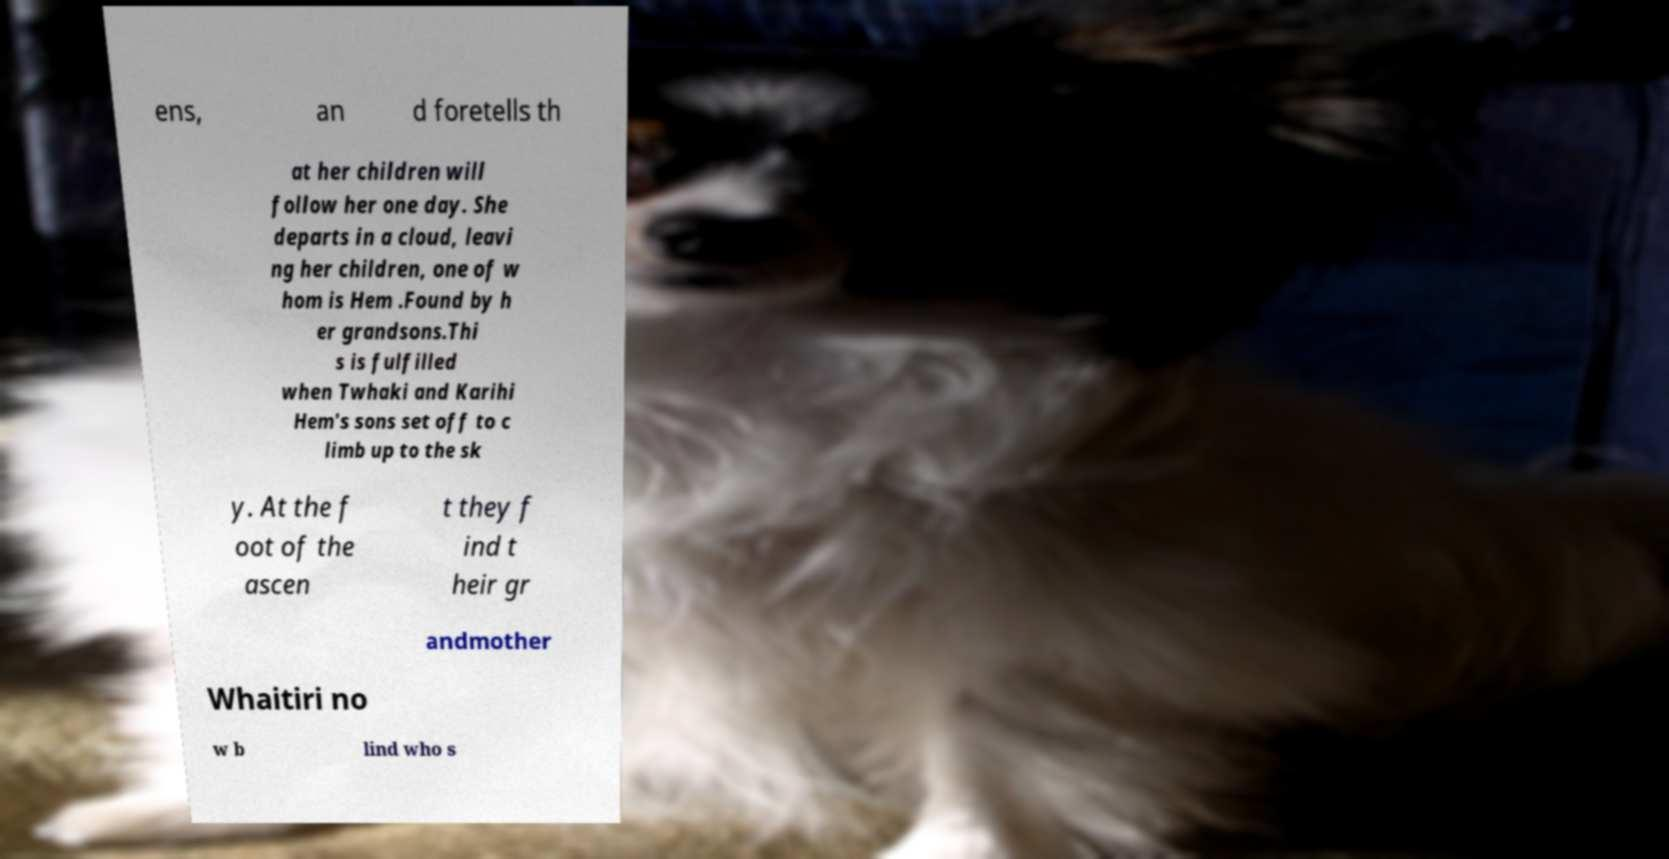Please read and relay the text visible in this image. What does it say? ens, an d foretells th at her children will follow her one day. She departs in a cloud, leavi ng her children, one of w hom is Hem .Found by h er grandsons.Thi s is fulfilled when Twhaki and Karihi Hem's sons set off to c limb up to the sk y. At the f oot of the ascen t they f ind t heir gr andmother Whaitiri no w b lind who s 